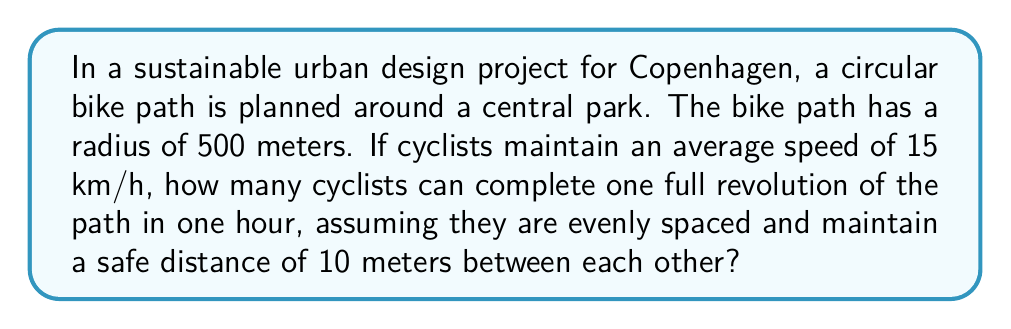Help me with this question. Let's approach this step-by-step:

1. Calculate the circumference of the circular bike path:
   $$C = 2\pi r$$
   where $r$ is the radius (500 meters)
   $$C = 2\pi(500) \approx 3141.59 \text{ meters}$$

2. Convert the cyclist speed from km/h to m/h:
   $$15 \text{ km/h} = 15000 \text{ m/h}$$

3. Calculate how many full revolutions a single cyclist can make in one hour:
   $$\text{Revolutions per hour} = \frac{15000 \text{ m/h}}{3141.59 \text{ m}} \approx 4.77$$

4. Calculate the time for one revolution:
   $$\text{Time per revolution} = \frac{1 \text{ hour}}{4.77} \approx 0.21 \text{ hours} = 12.6 \text{ minutes}$$

5. Determine the number of cyclists that can fit on the path with 10-meter spacing:
   $$\text{Number of cyclists} = \frac{3141.59 \text{ m}}{10 \text{ m}} \approx 314$$

6. Calculate how many groups of 314 cyclists can complete the revolution in one hour:
   $$\text{Groups per hour} = \frac{1 \text{ hour}}{0.21 \text{ hours}} \approx 4.77$$

7. Multiply the number of cyclists per group by the number of groups per hour:
   $$\text{Total cyclists per hour} = 314 \times 4.77 \approx 1498$$

Therefore, approximately 1498 cyclists can complete one full revolution of the path in one hour.
Answer: 1498 cyclists 